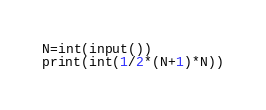<code> <loc_0><loc_0><loc_500><loc_500><_Python_>N=int(input())
print(int(1/2*(N+1)*N))</code> 